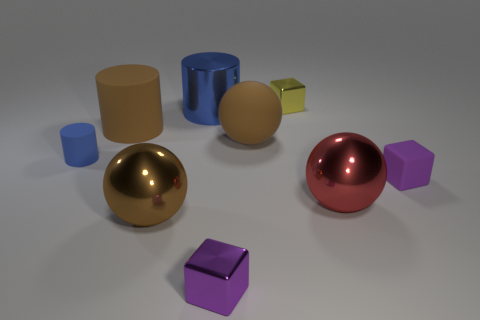Are there any other things that are the same size as the brown metallic thing?
Make the answer very short. Yes. What number of yellow things are matte objects or tiny blocks?
Keep it short and to the point. 1. What number of balls are the same size as the blue metal thing?
Your answer should be very brief. 3. What color is the object that is behind the big red metal thing and on the right side of the tiny yellow cube?
Keep it short and to the point. Purple. Are there more purple matte objects left of the red thing than small blue cylinders?
Ensure brevity in your answer.  No. Is there a big green metal object?
Give a very brief answer. No. Is the color of the rubber block the same as the metal cylinder?
Your response must be concise. No. What number of small objects are purple matte objects or blue blocks?
Offer a terse response. 1. Are there any other things that are the same color as the metallic cylinder?
Give a very brief answer. Yes. What shape is the large blue thing that is made of the same material as the yellow thing?
Offer a terse response. Cylinder. 